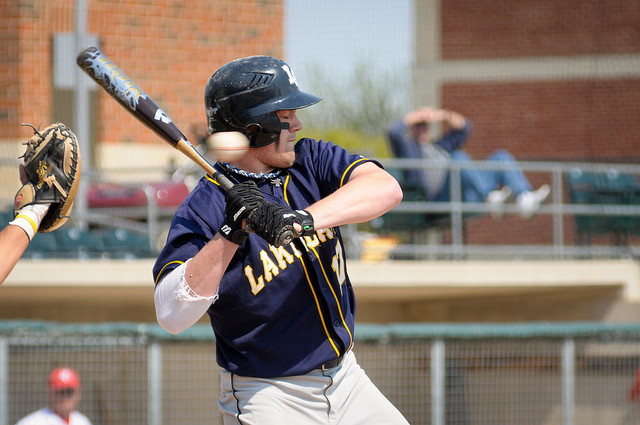Identify and read out the text in this image. LAK 3 4 